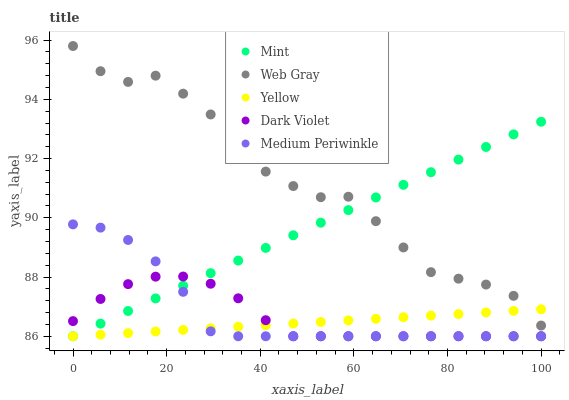Does Yellow have the minimum area under the curve?
Answer yes or no. Yes. Does Web Gray have the maximum area under the curve?
Answer yes or no. Yes. Does Mint have the minimum area under the curve?
Answer yes or no. No. Does Mint have the maximum area under the curve?
Answer yes or no. No. Is Mint the smoothest?
Answer yes or no. Yes. Is Web Gray the roughest?
Answer yes or no. Yes. Is Web Gray the smoothest?
Answer yes or no. No. Is Mint the roughest?
Answer yes or no. No. Does Medium Periwinkle have the lowest value?
Answer yes or no. Yes. Does Web Gray have the lowest value?
Answer yes or no. No. Does Web Gray have the highest value?
Answer yes or no. Yes. Does Mint have the highest value?
Answer yes or no. No. Is Medium Periwinkle less than Web Gray?
Answer yes or no. Yes. Is Web Gray greater than Medium Periwinkle?
Answer yes or no. Yes. Does Yellow intersect Medium Periwinkle?
Answer yes or no. Yes. Is Yellow less than Medium Periwinkle?
Answer yes or no. No. Is Yellow greater than Medium Periwinkle?
Answer yes or no. No. Does Medium Periwinkle intersect Web Gray?
Answer yes or no. No. 